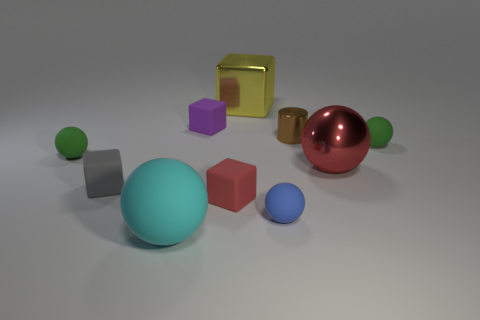What color is the large ball to the left of the metallic cylinder?
Your answer should be compact. Cyan. How many balls are either metallic things or tiny purple things?
Your answer should be compact. 1. What size is the rubber thing to the right of the blue object in front of the small purple rubber cube?
Your answer should be very brief. Small. Do the metallic ball and the tiny cube in front of the tiny gray matte object have the same color?
Your answer should be compact. Yes. There is a large yellow shiny block; what number of large metallic spheres are behind it?
Provide a succinct answer. 0. Is the number of big matte spheres less than the number of cyan metal cylinders?
Your answer should be compact. No. There is a matte cube that is both right of the cyan rubber ball and in front of the purple matte object; how big is it?
Keep it short and to the point. Small. There is a rubber block in front of the gray rubber block; does it have the same color as the large metal sphere?
Ensure brevity in your answer.  Yes. Are there fewer gray objects on the right side of the small gray matte thing than tiny matte objects?
Provide a short and direct response. Yes. What shape is the cyan thing that is the same material as the gray object?
Your answer should be compact. Sphere. 